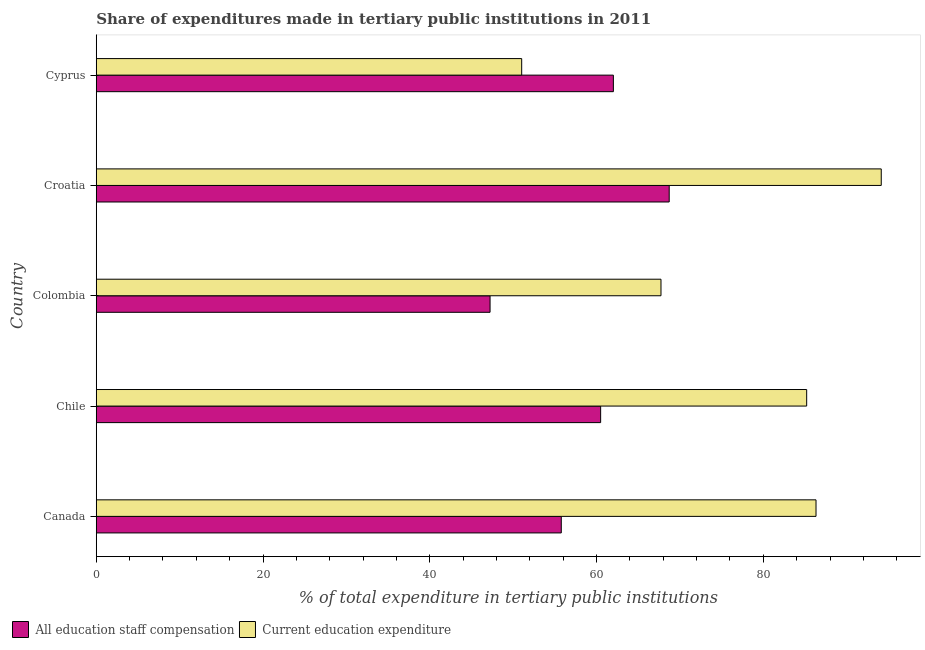How many different coloured bars are there?
Your response must be concise. 2. How many groups of bars are there?
Make the answer very short. 5. Are the number of bars on each tick of the Y-axis equal?
Keep it short and to the point. Yes. How many bars are there on the 1st tick from the bottom?
Offer a very short reply. 2. In how many cases, is the number of bars for a given country not equal to the number of legend labels?
Offer a terse response. 0. What is the expenditure in staff compensation in Chile?
Your response must be concise. 60.49. Across all countries, what is the maximum expenditure in education?
Offer a terse response. 94.14. Across all countries, what is the minimum expenditure in staff compensation?
Give a very brief answer. 47.23. In which country was the expenditure in staff compensation maximum?
Your answer should be very brief. Croatia. In which country was the expenditure in education minimum?
Offer a very short reply. Cyprus. What is the total expenditure in staff compensation in the graph?
Offer a terse response. 294.21. What is the difference between the expenditure in staff compensation in Canada and that in Croatia?
Keep it short and to the point. -12.94. What is the difference between the expenditure in staff compensation in Croatia and the expenditure in education in Chile?
Your answer should be very brief. -16.49. What is the average expenditure in staff compensation per country?
Make the answer very short. 58.84. What is the difference between the expenditure in education and expenditure in staff compensation in Colombia?
Provide a short and direct response. 20.5. In how many countries, is the expenditure in staff compensation greater than 40 %?
Make the answer very short. 5. What is the ratio of the expenditure in staff compensation in Canada to that in Chile?
Give a very brief answer. 0.92. Is the expenditure in education in Canada less than that in Colombia?
Your answer should be compact. No. What is the difference between the highest and the second highest expenditure in staff compensation?
Your answer should be compact. 6.7. What is the difference between the highest and the lowest expenditure in education?
Provide a succinct answer. 43.12. In how many countries, is the expenditure in staff compensation greater than the average expenditure in staff compensation taken over all countries?
Offer a very short reply. 3. Is the sum of the expenditure in education in Canada and Cyprus greater than the maximum expenditure in staff compensation across all countries?
Your answer should be compact. Yes. What does the 1st bar from the top in Canada represents?
Ensure brevity in your answer.  Current education expenditure. What does the 2nd bar from the bottom in Chile represents?
Keep it short and to the point. Current education expenditure. How many bars are there?
Provide a short and direct response. 10. What is the difference between two consecutive major ticks on the X-axis?
Offer a terse response. 20. Are the values on the major ticks of X-axis written in scientific E-notation?
Provide a succinct answer. No. Does the graph contain grids?
Make the answer very short. No. How are the legend labels stacked?
Your answer should be very brief. Horizontal. What is the title of the graph?
Give a very brief answer. Share of expenditures made in tertiary public institutions in 2011. Does "Goods" appear as one of the legend labels in the graph?
Keep it short and to the point. No. What is the label or title of the X-axis?
Give a very brief answer. % of total expenditure in tertiary public institutions. What is the % of total expenditure in tertiary public institutions in All education staff compensation in Canada?
Provide a succinct answer. 55.77. What is the % of total expenditure in tertiary public institutions of Current education expenditure in Canada?
Provide a succinct answer. 86.32. What is the % of total expenditure in tertiary public institutions of All education staff compensation in Chile?
Keep it short and to the point. 60.49. What is the % of total expenditure in tertiary public institutions of Current education expenditure in Chile?
Provide a short and direct response. 85.2. What is the % of total expenditure in tertiary public institutions of All education staff compensation in Colombia?
Your answer should be compact. 47.23. What is the % of total expenditure in tertiary public institutions in Current education expenditure in Colombia?
Your response must be concise. 67.72. What is the % of total expenditure in tertiary public institutions of All education staff compensation in Croatia?
Provide a succinct answer. 68.71. What is the % of total expenditure in tertiary public institutions of Current education expenditure in Croatia?
Make the answer very short. 94.14. What is the % of total expenditure in tertiary public institutions in All education staff compensation in Cyprus?
Keep it short and to the point. 62.01. What is the % of total expenditure in tertiary public institutions of Current education expenditure in Cyprus?
Offer a terse response. 51.02. Across all countries, what is the maximum % of total expenditure in tertiary public institutions of All education staff compensation?
Keep it short and to the point. 68.71. Across all countries, what is the maximum % of total expenditure in tertiary public institutions of Current education expenditure?
Provide a succinct answer. 94.14. Across all countries, what is the minimum % of total expenditure in tertiary public institutions in All education staff compensation?
Keep it short and to the point. 47.23. Across all countries, what is the minimum % of total expenditure in tertiary public institutions in Current education expenditure?
Offer a very short reply. 51.02. What is the total % of total expenditure in tertiary public institutions of All education staff compensation in the graph?
Offer a terse response. 294.21. What is the total % of total expenditure in tertiary public institutions in Current education expenditure in the graph?
Make the answer very short. 384.4. What is the difference between the % of total expenditure in tertiary public institutions of All education staff compensation in Canada and that in Chile?
Your response must be concise. -4.72. What is the difference between the % of total expenditure in tertiary public institutions of Current education expenditure in Canada and that in Chile?
Your answer should be very brief. 1.12. What is the difference between the % of total expenditure in tertiary public institutions in All education staff compensation in Canada and that in Colombia?
Provide a short and direct response. 8.54. What is the difference between the % of total expenditure in tertiary public institutions in Current education expenditure in Canada and that in Colombia?
Make the answer very short. 18.59. What is the difference between the % of total expenditure in tertiary public institutions of All education staff compensation in Canada and that in Croatia?
Ensure brevity in your answer.  -12.94. What is the difference between the % of total expenditure in tertiary public institutions of Current education expenditure in Canada and that in Croatia?
Give a very brief answer. -7.82. What is the difference between the % of total expenditure in tertiary public institutions in All education staff compensation in Canada and that in Cyprus?
Your response must be concise. -6.25. What is the difference between the % of total expenditure in tertiary public institutions in Current education expenditure in Canada and that in Cyprus?
Offer a terse response. 35.3. What is the difference between the % of total expenditure in tertiary public institutions of All education staff compensation in Chile and that in Colombia?
Make the answer very short. 13.26. What is the difference between the % of total expenditure in tertiary public institutions in Current education expenditure in Chile and that in Colombia?
Give a very brief answer. 17.47. What is the difference between the % of total expenditure in tertiary public institutions of All education staff compensation in Chile and that in Croatia?
Offer a very short reply. -8.22. What is the difference between the % of total expenditure in tertiary public institutions of Current education expenditure in Chile and that in Croatia?
Your answer should be very brief. -8.94. What is the difference between the % of total expenditure in tertiary public institutions of All education staff compensation in Chile and that in Cyprus?
Keep it short and to the point. -1.53. What is the difference between the % of total expenditure in tertiary public institutions in Current education expenditure in Chile and that in Cyprus?
Offer a terse response. 34.18. What is the difference between the % of total expenditure in tertiary public institutions of All education staff compensation in Colombia and that in Croatia?
Offer a terse response. -21.48. What is the difference between the % of total expenditure in tertiary public institutions in Current education expenditure in Colombia and that in Croatia?
Keep it short and to the point. -26.41. What is the difference between the % of total expenditure in tertiary public institutions of All education staff compensation in Colombia and that in Cyprus?
Offer a terse response. -14.79. What is the difference between the % of total expenditure in tertiary public institutions of Current education expenditure in Colombia and that in Cyprus?
Offer a terse response. 16.71. What is the difference between the % of total expenditure in tertiary public institutions of All education staff compensation in Croatia and that in Cyprus?
Keep it short and to the point. 6.7. What is the difference between the % of total expenditure in tertiary public institutions of Current education expenditure in Croatia and that in Cyprus?
Your response must be concise. 43.12. What is the difference between the % of total expenditure in tertiary public institutions in All education staff compensation in Canada and the % of total expenditure in tertiary public institutions in Current education expenditure in Chile?
Your answer should be very brief. -29.43. What is the difference between the % of total expenditure in tertiary public institutions of All education staff compensation in Canada and the % of total expenditure in tertiary public institutions of Current education expenditure in Colombia?
Make the answer very short. -11.96. What is the difference between the % of total expenditure in tertiary public institutions of All education staff compensation in Canada and the % of total expenditure in tertiary public institutions of Current education expenditure in Croatia?
Provide a succinct answer. -38.37. What is the difference between the % of total expenditure in tertiary public institutions in All education staff compensation in Canada and the % of total expenditure in tertiary public institutions in Current education expenditure in Cyprus?
Offer a terse response. 4.75. What is the difference between the % of total expenditure in tertiary public institutions in All education staff compensation in Chile and the % of total expenditure in tertiary public institutions in Current education expenditure in Colombia?
Ensure brevity in your answer.  -7.24. What is the difference between the % of total expenditure in tertiary public institutions in All education staff compensation in Chile and the % of total expenditure in tertiary public institutions in Current education expenditure in Croatia?
Provide a short and direct response. -33.65. What is the difference between the % of total expenditure in tertiary public institutions of All education staff compensation in Chile and the % of total expenditure in tertiary public institutions of Current education expenditure in Cyprus?
Your response must be concise. 9.47. What is the difference between the % of total expenditure in tertiary public institutions of All education staff compensation in Colombia and the % of total expenditure in tertiary public institutions of Current education expenditure in Croatia?
Your response must be concise. -46.91. What is the difference between the % of total expenditure in tertiary public institutions in All education staff compensation in Colombia and the % of total expenditure in tertiary public institutions in Current education expenditure in Cyprus?
Make the answer very short. -3.79. What is the difference between the % of total expenditure in tertiary public institutions in All education staff compensation in Croatia and the % of total expenditure in tertiary public institutions in Current education expenditure in Cyprus?
Offer a very short reply. 17.69. What is the average % of total expenditure in tertiary public institutions in All education staff compensation per country?
Keep it short and to the point. 58.84. What is the average % of total expenditure in tertiary public institutions in Current education expenditure per country?
Ensure brevity in your answer.  76.88. What is the difference between the % of total expenditure in tertiary public institutions of All education staff compensation and % of total expenditure in tertiary public institutions of Current education expenditure in Canada?
Provide a short and direct response. -30.55. What is the difference between the % of total expenditure in tertiary public institutions of All education staff compensation and % of total expenditure in tertiary public institutions of Current education expenditure in Chile?
Provide a succinct answer. -24.71. What is the difference between the % of total expenditure in tertiary public institutions of All education staff compensation and % of total expenditure in tertiary public institutions of Current education expenditure in Colombia?
Offer a very short reply. -20.5. What is the difference between the % of total expenditure in tertiary public institutions of All education staff compensation and % of total expenditure in tertiary public institutions of Current education expenditure in Croatia?
Give a very brief answer. -25.43. What is the difference between the % of total expenditure in tertiary public institutions of All education staff compensation and % of total expenditure in tertiary public institutions of Current education expenditure in Cyprus?
Ensure brevity in your answer.  10.99. What is the ratio of the % of total expenditure in tertiary public institutions of All education staff compensation in Canada to that in Chile?
Make the answer very short. 0.92. What is the ratio of the % of total expenditure in tertiary public institutions of Current education expenditure in Canada to that in Chile?
Your response must be concise. 1.01. What is the ratio of the % of total expenditure in tertiary public institutions in All education staff compensation in Canada to that in Colombia?
Your answer should be compact. 1.18. What is the ratio of the % of total expenditure in tertiary public institutions of Current education expenditure in Canada to that in Colombia?
Provide a succinct answer. 1.27. What is the ratio of the % of total expenditure in tertiary public institutions in All education staff compensation in Canada to that in Croatia?
Give a very brief answer. 0.81. What is the ratio of the % of total expenditure in tertiary public institutions of Current education expenditure in Canada to that in Croatia?
Provide a succinct answer. 0.92. What is the ratio of the % of total expenditure in tertiary public institutions in All education staff compensation in Canada to that in Cyprus?
Provide a succinct answer. 0.9. What is the ratio of the % of total expenditure in tertiary public institutions in Current education expenditure in Canada to that in Cyprus?
Your response must be concise. 1.69. What is the ratio of the % of total expenditure in tertiary public institutions of All education staff compensation in Chile to that in Colombia?
Offer a terse response. 1.28. What is the ratio of the % of total expenditure in tertiary public institutions in Current education expenditure in Chile to that in Colombia?
Provide a short and direct response. 1.26. What is the ratio of the % of total expenditure in tertiary public institutions in All education staff compensation in Chile to that in Croatia?
Ensure brevity in your answer.  0.88. What is the ratio of the % of total expenditure in tertiary public institutions of Current education expenditure in Chile to that in Croatia?
Offer a very short reply. 0.91. What is the ratio of the % of total expenditure in tertiary public institutions in All education staff compensation in Chile to that in Cyprus?
Offer a terse response. 0.98. What is the ratio of the % of total expenditure in tertiary public institutions in Current education expenditure in Chile to that in Cyprus?
Your answer should be very brief. 1.67. What is the ratio of the % of total expenditure in tertiary public institutions of All education staff compensation in Colombia to that in Croatia?
Your answer should be compact. 0.69. What is the ratio of the % of total expenditure in tertiary public institutions in Current education expenditure in Colombia to that in Croatia?
Ensure brevity in your answer.  0.72. What is the ratio of the % of total expenditure in tertiary public institutions of All education staff compensation in Colombia to that in Cyprus?
Offer a very short reply. 0.76. What is the ratio of the % of total expenditure in tertiary public institutions of Current education expenditure in Colombia to that in Cyprus?
Your answer should be compact. 1.33. What is the ratio of the % of total expenditure in tertiary public institutions in All education staff compensation in Croatia to that in Cyprus?
Your answer should be compact. 1.11. What is the ratio of the % of total expenditure in tertiary public institutions in Current education expenditure in Croatia to that in Cyprus?
Offer a very short reply. 1.85. What is the difference between the highest and the second highest % of total expenditure in tertiary public institutions in All education staff compensation?
Your answer should be compact. 6.7. What is the difference between the highest and the second highest % of total expenditure in tertiary public institutions of Current education expenditure?
Provide a succinct answer. 7.82. What is the difference between the highest and the lowest % of total expenditure in tertiary public institutions in All education staff compensation?
Keep it short and to the point. 21.48. What is the difference between the highest and the lowest % of total expenditure in tertiary public institutions of Current education expenditure?
Your answer should be compact. 43.12. 